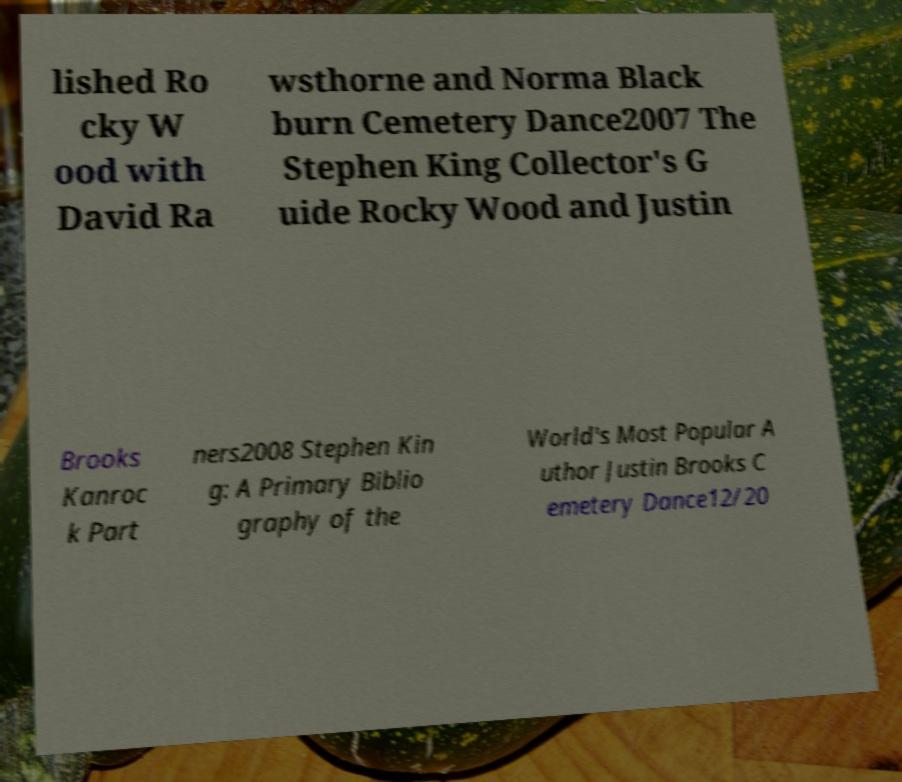What messages or text are displayed in this image? I need them in a readable, typed format. lished Ro cky W ood with David Ra wsthorne and Norma Black burn Cemetery Dance2007 The Stephen King Collector's G uide Rocky Wood and Justin Brooks Kanroc k Part ners2008 Stephen Kin g: A Primary Biblio graphy of the World's Most Popular A uthor Justin Brooks C emetery Dance12/20 